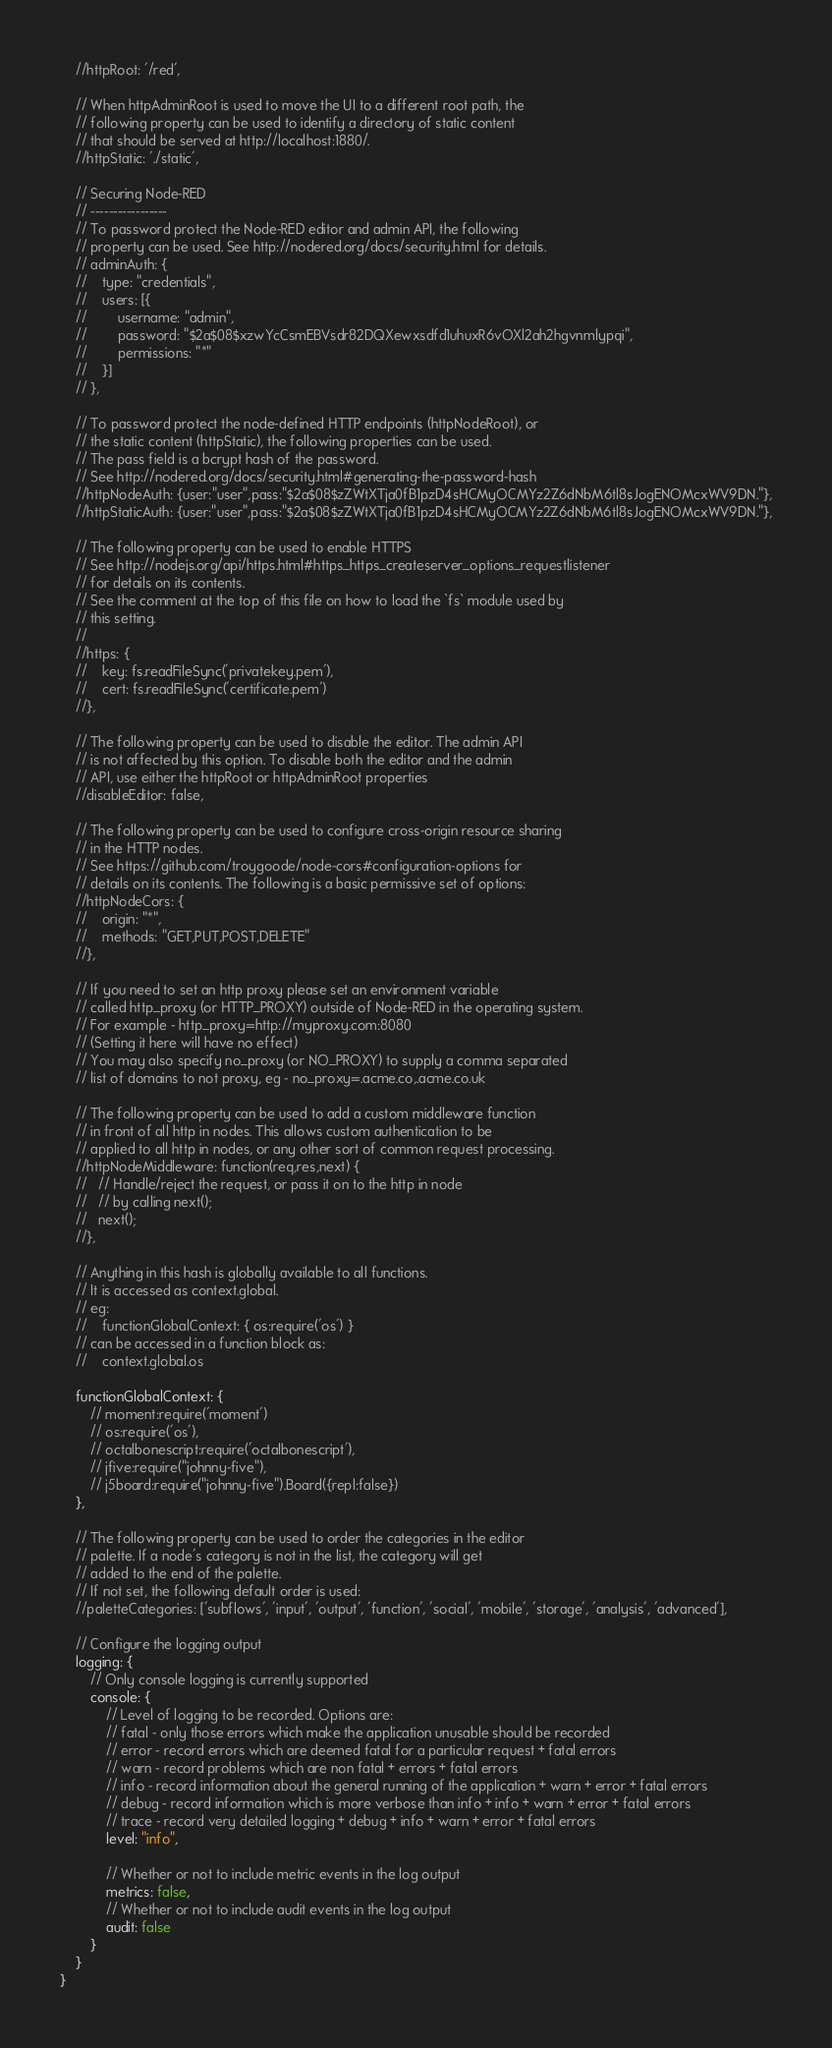Convert code to text. <code><loc_0><loc_0><loc_500><loc_500><_JavaScript_>    //httpRoot: '/red',

    // When httpAdminRoot is used to move the UI to a different root path, the
    // following property can be used to identify a directory of static content
    // that should be served at http://localhost:1880/.
    //httpStatic: './static',

    // Securing Node-RED
    // -----------------
    // To password protect the Node-RED editor and admin API, the following
    // property can be used. See http://nodered.org/docs/security.html for details.
    // adminAuth: {
    //    type: "credentials",
    //    users: [{
    //        username: "admin",
    //        password: "$2a$08$xzwYcCsmEBVsdr82DQXewxsdfd1uhuxR6vOXl2ah2hgvnmlypqi",
    //        permissions: "*"
    //    }]
    // },

    // To password protect the node-defined HTTP endpoints (httpNodeRoot), or
    // the static content (httpStatic), the following properties can be used.
    // The pass field is a bcrypt hash of the password.
    // See http://nodered.org/docs/security.html#generating-the-password-hash
    //httpNodeAuth: {user:"user",pass:"$2a$08$zZWtXTja0fB1pzD4sHCMyOCMYz2Z6dNbM6tl8sJogENOMcxWV9DN."},
    //httpStaticAuth: {user:"user",pass:"$2a$08$zZWtXTja0fB1pzD4sHCMyOCMYz2Z6dNbM6tl8sJogENOMcxWV9DN."},

    // The following property can be used to enable HTTPS
    // See http://nodejs.org/api/https.html#https_https_createserver_options_requestlistener
    // for details on its contents.
    // See the comment at the top of this file on how to load the `fs` module used by
    // this setting.
    //
    //https: {
    //    key: fs.readFileSync('privatekey.pem'),
    //    cert: fs.readFileSync('certificate.pem')
    //},

    // The following property can be used to disable the editor. The admin API
    // is not affected by this option. To disable both the editor and the admin
    // API, use either the httpRoot or httpAdminRoot properties
    //disableEditor: false,

    // The following property can be used to configure cross-origin resource sharing
    // in the HTTP nodes.
    // See https://github.com/troygoode/node-cors#configuration-options for
    // details on its contents. The following is a basic permissive set of options:
    //httpNodeCors: {
    //    origin: "*",
    //    methods: "GET,PUT,POST,DELETE"
    //},

    // If you need to set an http proxy please set an environment variable
    // called http_proxy (or HTTP_PROXY) outside of Node-RED in the operating system.
    // For example - http_proxy=http://myproxy.com:8080
    // (Setting it here will have no effect)
    // You may also specify no_proxy (or NO_PROXY) to supply a comma separated
    // list of domains to not proxy, eg - no_proxy=.acme.co,.acme.co.uk

    // The following property can be used to add a custom middleware function
    // in front of all http in nodes. This allows custom authentication to be
    // applied to all http in nodes, or any other sort of common request processing.
    //httpNodeMiddleware: function(req,res,next) {
    //   // Handle/reject the request, or pass it on to the http in node
    //   // by calling next();
    //   next();
    //},

    // Anything in this hash is globally available to all functions.
    // It is accessed as context.global.
    // eg:
    //    functionGlobalContext: { os:require('os') }
    // can be accessed in a function block as:
    //    context.global.os

    functionGlobalContext: {
        // moment:require('moment')
        // os:require('os'),
        // octalbonescript:require('octalbonescript'),
        // jfive:require("johnny-five"),
        // j5board:require("johnny-five").Board({repl:false})
    },

    // The following property can be used to order the categories in the editor
    // palette. If a node's category is not in the list, the category will get
    // added to the end of the palette.
    // If not set, the following default order is used:
    //paletteCategories: ['subflows', 'input', 'output', 'function', 'social', 'mobile', 'storage', 'analysis', 'advanced'],

    // Configure the logging output
    logging: {
        // Only console logging is currently supported
        console: {
            // Level of logging to be recorded. Options are:
            // fatal - only those errors which make the application unusable should be recorded
            // error - record errors which are deemed fatal for a particular request + fatal errors
            // warn - record problems which are non fatal + errors + fatal errors
            // info - record information about the general running of the application + warn + error + fatal errors
            // debug - record information which is more verbose than info + info + warn + error + fatal errors
            // trace - record very detailed logging + debug + info + warn + error + fatal errors
            level: "info",

            // Whether or not to include metric events in the log output
            metrics: false,
            // Whether or not to include audit events in the log output
            audit: false
        }
    }
}
</code> 